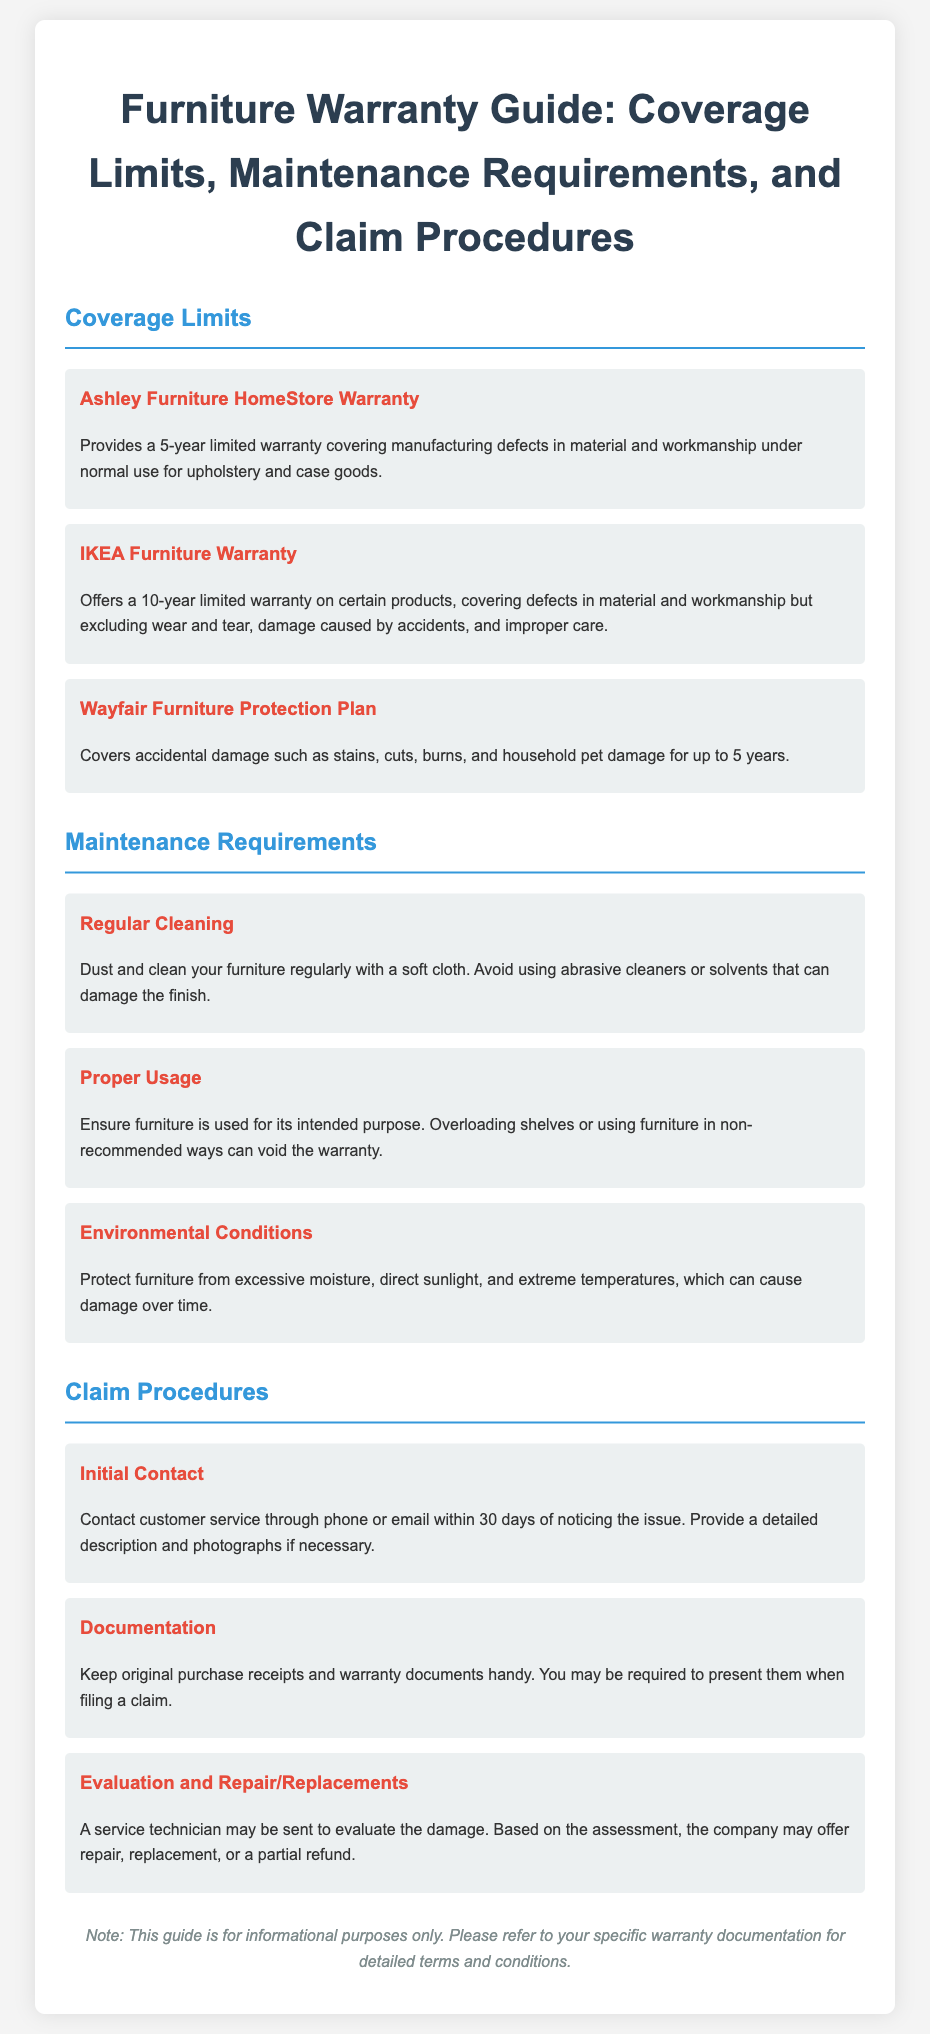What is the warranty period for Ashley Furniture? The warranty period for Ashley Furniture HomeStore is stated as a 5-year limited warranty covering manufacturing defects.
Answer: 5 years What type of damage does the Wayfair Furniture Protection Plan cover? The Wayfair Furniture Protection Plan covers accidental damage such as stains, cuts, burns, and household pet damage.
Answer: Accidental damage What is one of the maintenance requirements for furniture? The document mentions that regular cleaning is a maintenance requirement, advising to dust and clean your furniture regularly with a soft cloth.
Answer: Regular cleaning How long do you have to contact customer service to file a claim? The document states you must contact customer service within 30 days of noticing the issue to file a claim.
Answer: 30 days What is required when filing a claim? When filing a claim, you are required to keep original purchase receipts and warranty documents handy.
Answer: Original purchase receipts What will happen after a technician evaluates the damage? After evaluation, the company may offer repair, replacement, or a partial refund based on the assessment.
Answer: Repair, replacement, or partial refund What does the IKEA Furniture Warranty exclude? The IKEA Furniture Warranty excludes wear and tear, damage caused by accidents, and improper care from its coverage.
Answer: Wear and tear Which environmental condition can void the warranty? The warranty can be voided if the furniture is exposed to excessive moisture, direct sunlight, or extreme temperatures.
Answer: Excessive moisture What is the note at the end of the document? The note indicates that the guide is for informational purposes only, advising to refer to specific warranty documentation for detailed terms.
Answer: Informational purposes only 